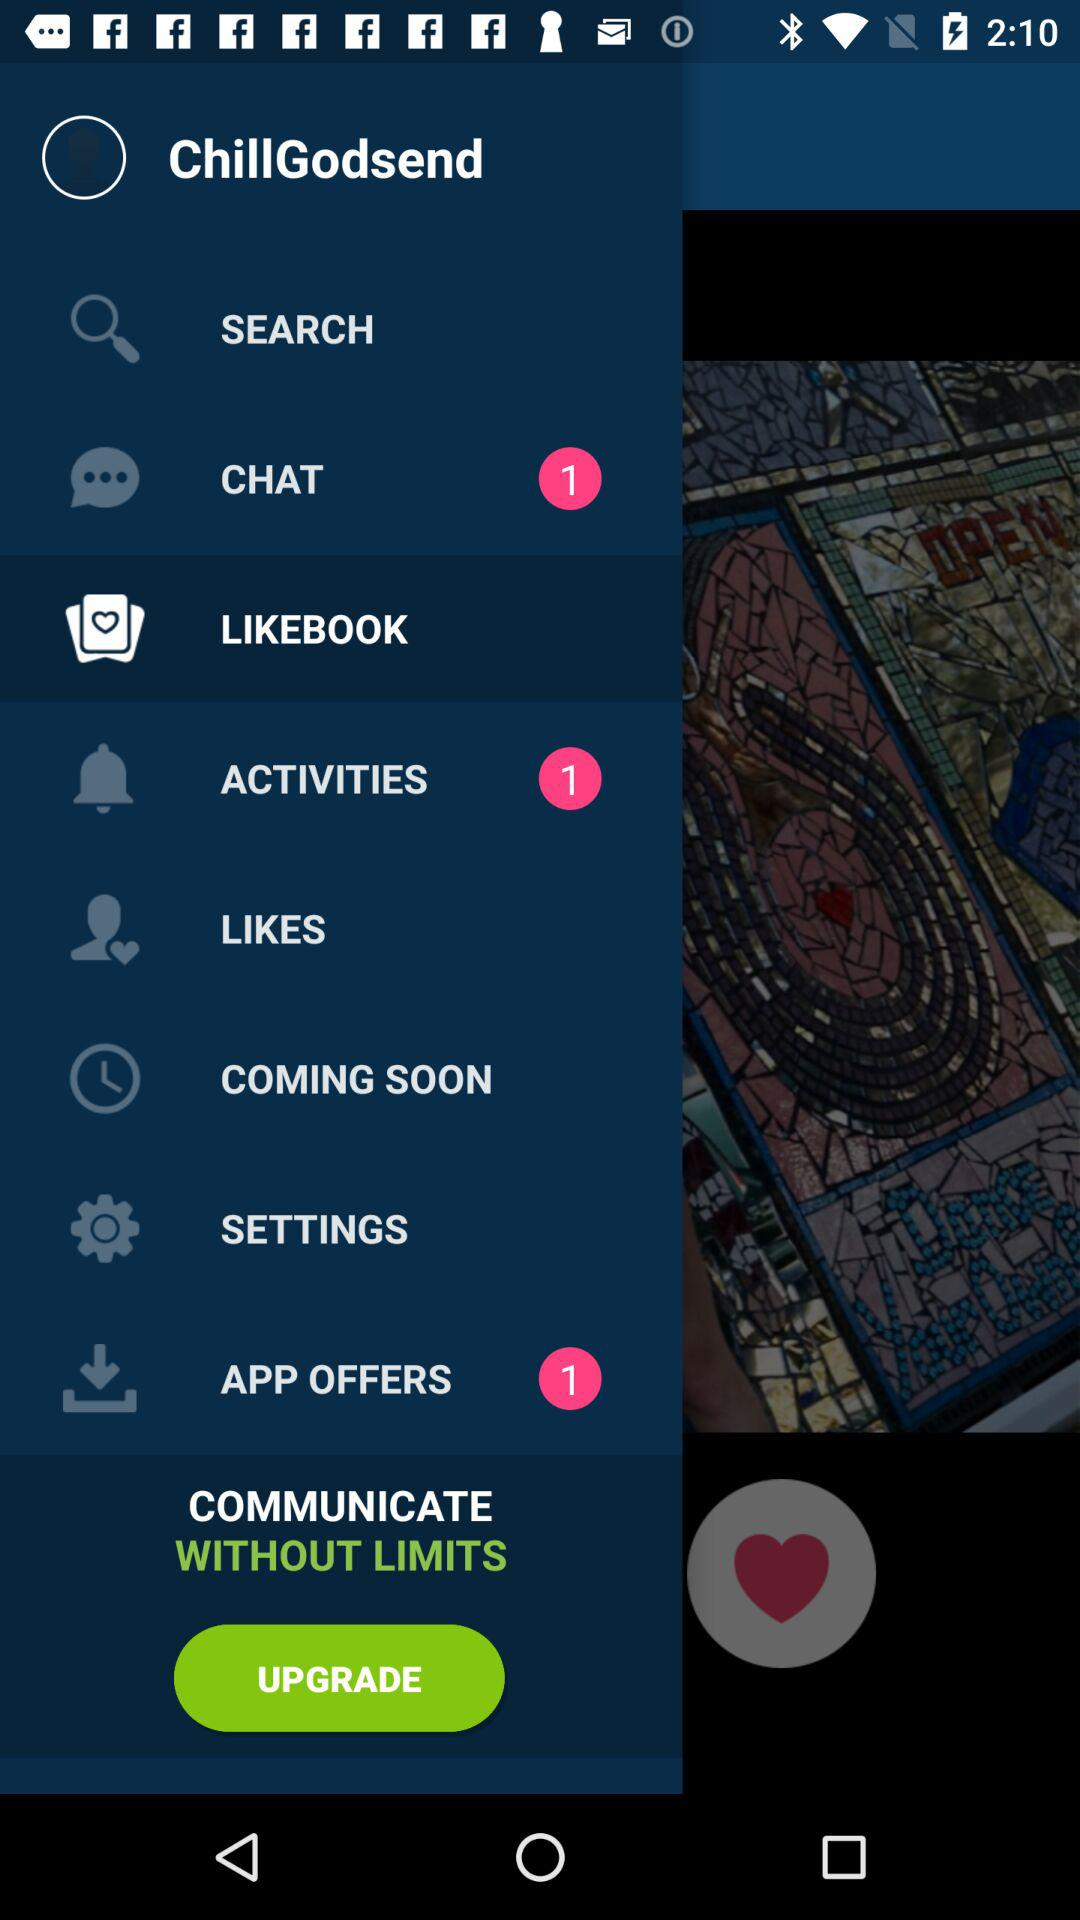Are there any unread chats? There is 1 unread chat. 